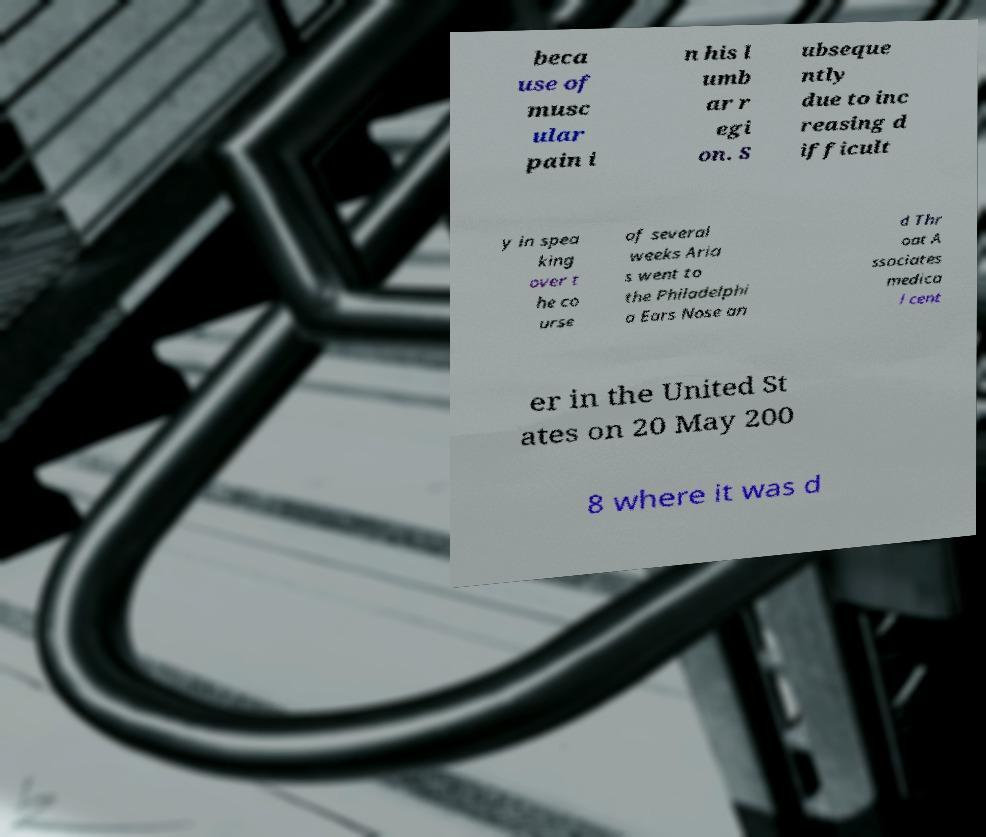For documentation purposes, I need the text within this image transcribed. Could you provide that? beca use of musc ular pain i n his l umb ar r egi on. S ubseque ntly due to inc reasing d ifficult y in spea king over t he co urse of several weeks Aria s went to the Philadelphi a Ears Nose an d Thr oat A ssociates medica l cent er in the United St ates on 20 May 200 8 where it was d 